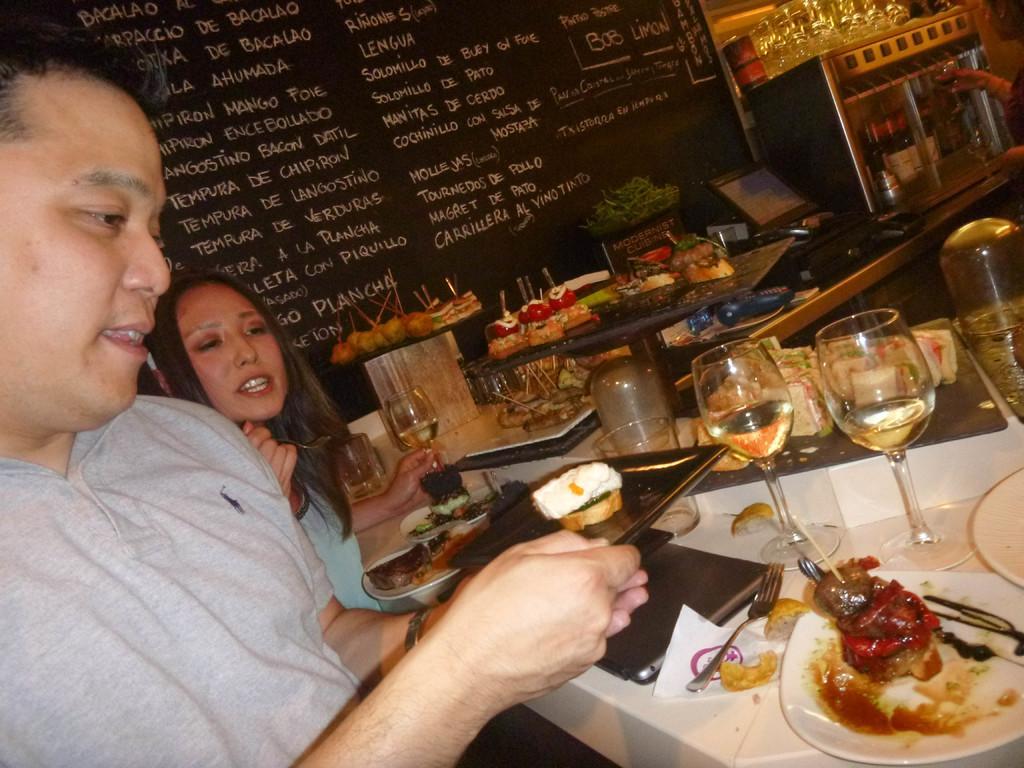Please provide a concise description of this image. There is a man holding a plate with food item. Near to him there is a lady holding a glass. In front of them there is a table. On that there are plates, glasses, forks, laptop and many other things. On the plates there are food items. In the back there is a wall with something written on that. 